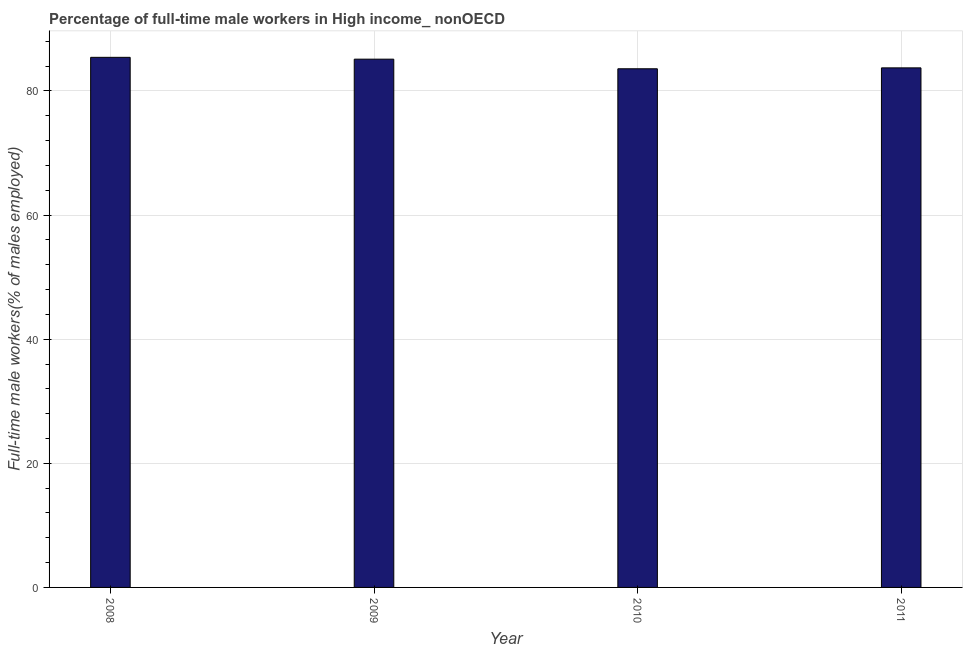Does the graph contain grids?
Your response must be concise. Yes. What is the title of the graph?
Your answer should be very brief. Percentage of full-time male workers in High income_ nonOECD. What is the label or title of the Y-axis?
Your response must be concise. Full-time male workers(% of males employed). What is the percentage of full-time male workers in 2009?
Offer a terse response. 85.12. Across all years, what is the maximum percentage of full-time male workers?
Offer a terse response. 85.42. Across all years, what is the minimum percentage of full-time male workers?
Ensure brevity in your answer.  83.58. What is the sum of the percentage of full-time male workers?
Ensure brevity in your answer.  337.84. What is the difference between the percentage of full-time male workers in 2010 and 2011?
Your response must be concise. -0.14. What is the average percentage of full-time male workers per year?
Make the answer very short. 84.46. What is the median percentage of full-time male workers?
Ensure brevity in your answer.  84.42. Do a majority of the years between 2009 and 2010 (inclusive) have percentage of full-time male workers greater than 12 %?
Ensure brevity in your answer.  Yes. What is the ratio of the percentage of full-time male workers in 2008 to that in 2010?
Provide a short and direct response. 1.02. Is the percentage of full-time male workers in 2008 less than that in 2009?
Your answer should be very brief. No. What is the difference between the highest and the second highest percentage of full-time male workers?
Provide a succinct answer. 0.29. Is the sum of the percentage of full-time male workers in 2009 and 2011 greater than the maximum percentage of full-time male workers across all years?
Your response must be concise. Yes. What is the difference between the highest and the lowest percentage of full-time male workers?
Provide a short and direct response. 1.84. In how many years, is the percentage of full-time male workers greater than the average percentage of full-time male workers taken over all years?
Provide a succinct answer. 2. What is the difference between two consecutive major ticks on the Y-axis?
Offer a very short reply. 20. Are the values on the major ticks of Y-axis written in scientific E-notation?
Make the answer very short. No. What is the Full-time male workers(% of males employed) of 2008?
Make the answer very short. 85.42. What is the Full-time male workers(% of males employed) in 2009?
Keep it short and to the point. 85.12. What is the Full-time male workers(% of males employed) of 2010?
Give a very brief answer. 83.58. What is the Full-time male workers(% of males employed) in 2011?
Keep it short and to the point. 83.72. What is the difference between the Full-time male workers(% of males employed) in 2008 and 2009?
Your response must be concise. 0.3. What is the difference between the Full-time male workers(% of males employed) in 2008 and 2010?
Your answer should be compact. 1.84. What is the difference between the Full-time male workers(% of males employed) in 2008 and 2011?
Provide a short and direct response. 1.7. What is the difference between the Full-time male workers(% of males employed) in 2009 and 2010?
Offer a terse response. 1.55. What is the difference between the Full-time male workers(% of males employed) in 2009 and 2011?
Your response must be concise. 1.4. What is the difference between the Full-time male workers(% of males employed) in 2010 and 2011?
Your response must be concise. -0.15. What is the ratio of the Full-time male workers(% of males employed) in 2008 to that in 2010?
Ensure brevity in your answer.  1.02. 